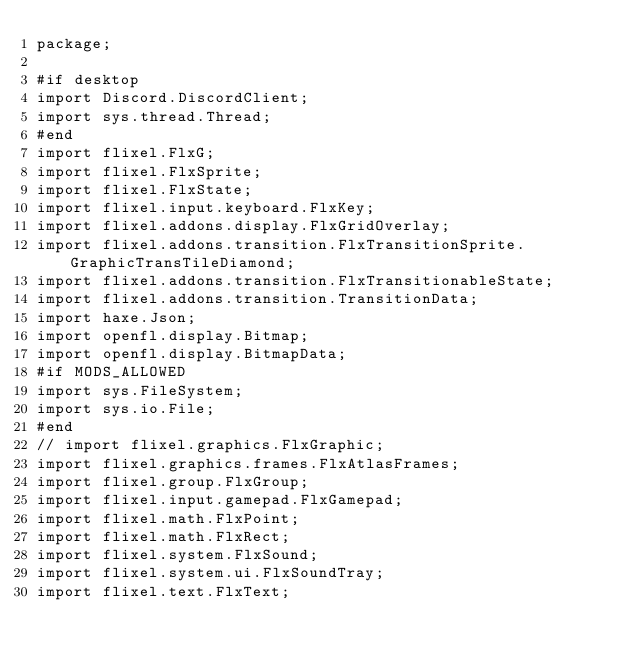Convert code to text. <code><loc_0><loc_0><loc_500><loc_500><_Haxe_>package;

#if desktop
import Discord.DiscordClient;
import sys.thread.Thread;
#end
import flixel.FlxG;
import flixel.FlxSprite;
import flixel.FlxState;
import flixel.input.keyboard.FlxKey;
import flixel.addons.display.FlxGridOverlay;
import flixel.addons.transition.FlxTransitionSprite.GraphicTransTileDiamond;
import flixel.addons.transition.FlxTransitionableState;
import flixel.addons.transition.TransitionData;
import haxe.Json;
import openfl.display.Bitmap;
import openfl.display.BitmapData;
#if MODS_ALLOWED
import sys.FileSystem;
import sys.io.File;
#end
// import flixel.graphics.FlxGraphic;
import flixel.graphics.frames.FlxAtlasFrames;
import flixel.group.FlxGroup;
import flixel.input.gamepad.FlxGamepad;
import flixel.math.FlxPoint;
import flixel.math.FlxRect;
import flixel.system.FlxSound;
import flixel.system.ui.FlxSoundTray;
import flixel.text.FlxText;</code> 